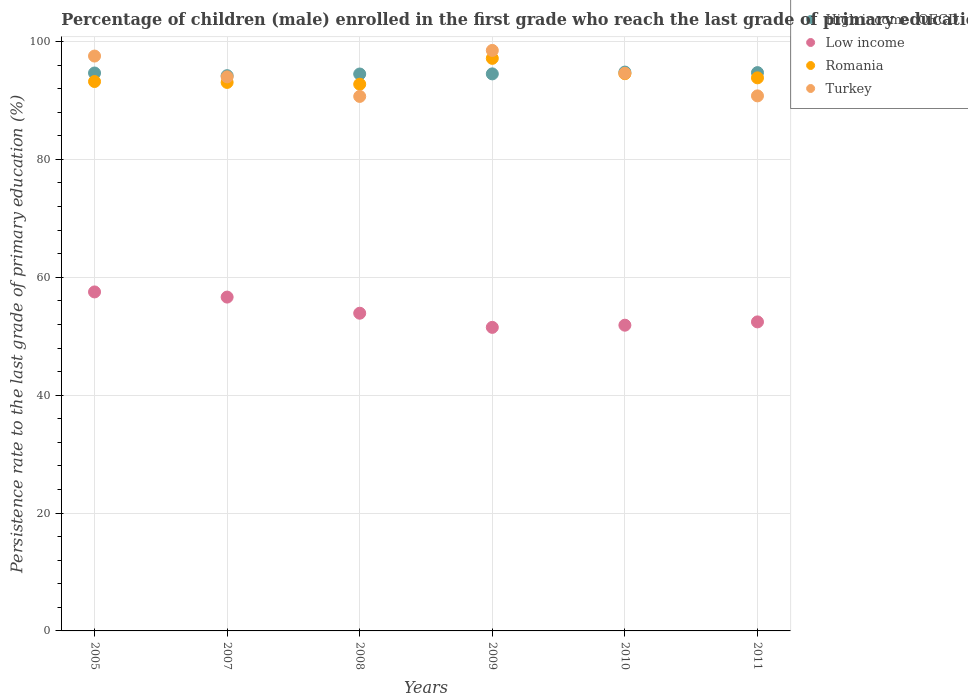Is the number of dotlines equal to the number of legend labels?
Your answer should be compact. Yes. What is the persistence rate of children in High income: OECD in 2010?
Your response must be concise. 94.81. Across all years, what is the maximum persistence rate of children in Romania?
Offer a very short reply. 97.14. Across all years, what is the minimum persistence rate of children in Romania?
Offer a terse response. 92.75. What is the total persistence rate of children in High income: OECD in the graph?
Keep it short and to the point. 567.39. What is the difference between the persistence rate of children in Turkey in 2009 and that in 2010?
Give a very brief answer. 3.88. What is the difference between the persistence rate of children in Low income in 2005 and the persistence rate of children in Romania in 2009?
Give a very brief answer. -39.63. What is the average persistence rate of children in Romania per year?
Offer a very short reply. 94.09. In the year 2011, what is the difference between the persistence rate of children in Low income and persistence rate of children in High income: OECD?
Your answer should be very brief. -42.29. What is the ratio of the persistence rate of children in Turkey in 2008 to that in 2010?
Offer a very short reply. 0.96. Is the persistence rate of children in High income: OECD in 2009 less than that in 2010?
Offer a terse response. Yes. Is the difference between the persistence rate of children in Low income in 2008 and 2010 greater than the difference between the persistence rate of children in High income: OECD in 2008 and 2010?
Offer a terse response. Yes. What is the difference between the highest and the second highest persistence rate of children in High income: OECD?
Provide a succinct answer. 0.09. What is the difference between the highest and the lowest persistence rate of children in High income: OECD?
Keep it short and to the point. 0.61. Is the sum of the persistence rate of children in Low income in 2005 and 2011 greater than the maximum persistence rate of children in Turkey across all years?
Give a very brief answer. Yes. Is it the case that in every year, the sum of the persistence rate of children in Turkey and persistence rate of children in Low income  is greater than the sum of persistence rate of children in Romania and persistence rate of children in High income: OECD?
Your answer should be very brief. No. Does the persistence rate of children in High income: OECD monotonically increase over the years?
Give a very brief answer. No. Is the persistence rate of children in Romania strictly less than the persistence rate of children in High income: OECD over the years?
Offer a terse response. No. How many dotlines are there?
Offer a very short reply. 4. How many years are there in the graph?
Your answer should be compact. 6. Are the values on the major ticks of Y-axis written in scientific E-notation?
Your answer should be compact. No. Does the graph contain any zero values?
Keep it short and to the point. No. Does the graph contain grids?
Offer a very short reply. Yes. What is the title of the graph?
Offer a terse response. Percentage of children (male) enrolled in the first grade who reach the last grade of primary education. What is the label or title of the X-axis?
Your response must be concise. Years. What is the label or title of the Y-axis?
Keep it short and to the point. Persistence rate to the last grade of primary education (%). What is the Persistence rate to the last grade of primary education (%) of High income: OECD in 2005?
Offer a very short reply. 94.66. What is the Persistence rate to the last grade of primary education (%) in Low income in 2005?
Provide a succinct answer. 57.51. What is the Persistence rate to the last grade of primary education (%) in Romania in 2005?
Offer a terse response. 93.21. What is the Persistence rate to the last grade of primary education (%) of Turkey in 2005?
Your answer should be compact. 97.53. What is the Persistence rate to the last grade of primary education (%) of High income: OECD in 2007?
Provide a short and direct response. 94.2. What is the Persistence rate to the last grade of primary education (%) in Low income in 2007?
Provide a succinct answer. 56.64. What is the Persistence rate to the last grade of primary education (%) of Romania in 2007?
Provide a short and direct response. 93.06. What is the Persistence rate to the last grade of primary education (%) of Turkey in 2007?
Offer a terse response. 94. What is the Persistence rate to the last grade of primary education (%) in High income: OECD in 2008?
Keep it short and to the point. 94.49. What is the Persistence rate to the last grade of primary education (%) in Low income in 2008?
Your answer should be very brief. 53.9. What is the Persistence rate to the last grade of primary education (%) of Romania in 2008?
Ensure brevity in your answer.  92.75. What is the Persistence rate to the last grade of primary education (%) of Turkey in 2008?
Provide a short and direct response. 90.68. What is the Persistence rate to the last grade of primary education (%) in High income: OECD in 2009?
Offer a terse response. 94.51. What is the Persistence rate to the last grade of primary education (%) in Low income in 2009?
Your answer should be very brief. 51.5. What is the Persistence rate to the last grade of primary education (%) of Romania in 2009?
Offer a terse response. 97.14. What is the Persistence rate to the last grade of primary education (%) of Turkey in 2009?
Offer a terse response. 98.49. What is the Persistence rate to the last grade of primary education (%) in High income: OECD in 2010?
Your response must be concise. 94.81. What is the Persistence rate to the last grade of primary education (%) in Low income in 2010?
Provide a succinct answer. 51.87. What is the Persistence rate to the last grade of primary education (%) in Romania in 2010?
Your response must be concise. 94.54. What is the Persistence rate to the last grade of primary education (%) of Turkey in 2010?
Provide a succinct answer. 94.61. What is the Persistence rate to the last grade of primary education (%) in High income: OECD in 2011?
Give a very brief answer. 94.72. What is the Persistence rate to the last grade of primary education (%) in Low income in 2011?
Your answer should be very brief. 52.43. What is the Persistence rate to the last grade of primary education (%) of Romania in 2011?
Give a very brief answer. 93.84. What is the Persistence rate to the last grade of primary education (%) of Turkey in 2011?
Offer a very short reply. 90.78. Across all years, what is the maximum Persistence rate to the last grade of primary education (%) of High income: OECD?
Provide a succinct answer. 94.81. Across all years, what is the maximum Persistence rate to the last grade of primary education (%) in Low income?
Offer a very short reply. 57.51. Across all years, what is the maximum Persistence rate to the last grade of primary education (%) in Romania?
Your answer should be very brief. 97.14. Across all years, what is the maximum Persistence rate to the last grade of primary education (%) of Turkey?
Your answer should be compact. 98.49. Across all years, what is the minimum Persistence rate to the last grade of primary education (%) in High income: OECD?
Give a very brief answer. 94.2. Across all years, what is the minimum Persistence rate to the last grade of primary education (%) in Low income?
Provide a succinct answer. 51.5. Across all years, what is the minimum Persistence rate to the last grade of primary education (%) of Romania?
Keep it short and to the point. 92.75. Across all years, what is the minimum Persistence rate to the last grade of primary education (%) of Turkey?
Your answer should be very brief. 90.68. What is the total Persistence rate to the last grade of primary education (%) in High income: OECD in the graph?
Provide a short and direct response. 567.39. What is the total Persistence rate to the last grade of primary education (%) in Low income in the graph?
Offer a very short reply. 323.85. What is the total Persistence rate to the last grade of primary education (%) of Romania in the graph?
Offer a terse response. 564.54. What is the total Persistence rate to the last grade of primary education (%) of Turkey in the graph?
Your answer should be compact. 566.09. What is the difference between the Persistence rate to the last grade of primary education (%) of High income: OECD in 2005 and that in 2007?
Provide a short and direct response. 0.45. What is the difference between the Persistence rate to the last grade of primary education (%) in Low income in 2005 and that in 2007?
Your answer should be very brief. 0.87. What is the difference between the Persistence rate to the last grade of primary education (%) in Romania in 2005 and that in 2007?
Provide a succinct answer. 0.15. What is the difference between the Persistence rate to the last grade of primary education (%) of Turkey in 2005 and that in 2007?
Your answer should be very brief. 3.53. What is the difference between the Persistence rate to the last grade of primary education (%) in High income: OECD in 2005 and that in 2008?
Your response must be concise. 0.17. What is the difference between the Persistence rate to the last grade of primary education (%) of Low income in 2005 and that in 2008?
Offer a very short reply. 3.61. What is the difference between the Persistence rate to the last grade of primary education (%) in Romania in 2005 and that in 2008?
Provide a short and direct response. 0.46. What is the difference between the Persistence rate to the last grade of primary education (%) of Turkey in 2005 and that in 2008?
Make the answer very short. 6.85. What is the difference between the Persistence rate to the last grade of primary education (%) in High income: OECD in 2005 and that in 2009?
Your response must be concise. 0.15. What is the difference between the Persistence rate to the last grade of primary education (%) of Low income in 2005 and that in 2009?
Your answer should be very brief. 6.01. What is the difference between the Persistence rate to the last grade of primary education (%) of Romania in 2005 and that in 2009?
Give a very brief answer. -3.93. What is the difference between the Persistence rate to the last grade of primary education (%) of Turkey in 2005 and that in 2009?
Keep it short and to the point. -0.95. What is the difference between the Persistence rate to the last grade of primary education (%) of High income: OECD in 2005 and that in 2010?
Keep it short and to the point. -0.16. What is the difference between the Persistence rate to the last grade of primary education (%) of Low income in 2005 and that in 2010?
Provide a short and direct response. 5.64. What is the difference between the Persistence rate to the last grade of primary education (%) in Romania in 2005 and that in 2010?
Offer a terse response. -1.33. What is the difference between the Persistence rate to the last grade of primary education (%) of Turkey in 2005 and that in 2010?
Provide a succinct answer. 2.92. What is the difference between the Persistence rate to the last grade of primary education (%) in High income: OECD in 2005 and that in 2011?
Offer a terse response. -0.07. What is the difference between the Persistence rate to the last grade of primary education (%) in Low income in 2005 and that in 2011?
Offer a very short reply. 5.08. What is the difference between the Persistence rate to the last grade of primary education (%) in Romania in 2005 and that in 2011?
Offer a very short reply. -0.62. What is the difference between the Persistence rate to the last grade of primary education (%) in Turkey in 2005 and that in 2011?
Make the answer very short. 6.76. What is the difference between the Persistence rate to the last grade of primary education (%) in High income: OECD in 2007 and that in 2008?
Make the answer very short. -0.28. What is the difference between the Persistence rate to the last grade of primary education (%) in Low income in 2007 and that in 2008?
Keep it short and to the point. 2.74. What is the difference between the Persistence rate to the last grade of primary education (%) in Romania in 2007 and that in 2008?
Provide a short and direct response. 0.3. What is the difference between the Persistence rate to the last grade of primary education (%) in Turkey in 2007 and that in 2008?
Give a very brief answer. 3.32. What is the difference between the Persistence rate to the last grade of primary education (%) in High income: OECD in 2007 and that in 2009?
Offer a terse response. -0.31. What is the difference between the Persistence rate to the last grade of primary education (%) of Low income in 2007 and that in 2009?
Ensure brevity in your answer.  5.14. What is the difference between the Persistence rate to the last grade of primary education (%) of Romania in 2007 and that in 2009?
Offer a terse response. -4.08. What is the difference between the Persistence rate to the last grade of primary education (%) in Turkey in 2007 and that in 2009?
Offer a very short reply. -4.49. What is the difference between the Persistence rate to the last grade of primary education (%) in High income: OECD in 2007 and that in 2010?
Give a very brief answer. -0.61. What is the difference between the Persistence rate to the last grade of primary education (%) in Low income in 2007 and that in 2010?
Give a very brief answer. 4.77. What is the difference between the Persistence rate to the last grade of primary education (%) of Romania in 2007 and that in 2010?
Your response must be concise. -1.48. What is the difference between the Persistence rate to the last grade of primary education (%) in Turkey in 2007 and that in 2010?
Provide a succinct answer. -0.61. What is the difference between the Persistence rate to the last grade of primary education (%) of High income: OECD in 2007 and that in 2011?
Give a very brief answer. -0.52. What is the difference between the Persistence rate to the last grade of primary education (%) of Low income in 2007 and that in 2011?
Provide a succinct answer. 4.21. What is the difference between the Persistence rate to the last grade of primary education (%) in Romania in 2007 and that in 2011?
Give a very brief answer. -0.78. What is the difference between the Persistence rate to the last grade of primary education (%) in Turkey in 2007 and that in 2011?
Make the answer very short. 3.23. What is the difference between the Persistence rate to the last grade of primary education (%) in High income: OECD in 2008 and that in 2009?
Keep it short and to the point. -0.02. What is the difference between the Persistence rate to the last grade of primary education (%) of Romania in 2008 and that in 2009?
Ensure brevity in your answer.  -4.39. What is the difference between the Persistence rate to the last grade of primary education (%) of Turkey in 2008 and that in 2009?
Your response must be concise. -7.8. What is the difference between the Persistence rate to the last grade of primary education (%) of High income: OECD in 2008 and that in 2010?
Provide a succinct answer. -0.33. What is the difference between the Persistence rate to the last grade of primary education (%) of Low income in 2008 and that in 2010?
Offer a terse response. 2.03. What is the difference between the Persistence rate to the last grade of primary education (%) in Romania in 2008 and that in 2010?
Offer a very short reply. -1.79. What is the difference between the Persistence rate to the last grade of primary education (%) in Turkey in 2008 and that in 2010?
Offer a terse response. -3.92. What is the difference between the Persistence rate to the last grade of primary education (%) of High income: OECD in 2008 and that in 2011?
Provide a short and direct response. -0.24. What is the difference between the Persistence rate to the last grade of primary education (%) of Low income in 2008 and that in 2011?
Keep it short and to the point. 1.47. What is the difference between the Persistence rate to the last grade of primary education (%) of Romania in 2008 and that in 2011?
Your response must be concise. -1.08. What is the difference between the Persistence rate to the last grade of primary education (%) in Turkey in 2008 and that in 2011?
Offer a very short reply. -0.09. What is the difference between the Persistence rate to the last grade of primary education (%) of High income: OECD in 2009 and that in 2010?
Make the answer very short. -0.31. What is the difference between the Persistence rate to the last grade of primary education (%) of Low income in 2009 and that in 2010?
Make the answer very short. -0.37. What is the difference between the Persistence rate to the last grade of primary education (%) in Romania in 2009 and that in 2010?
Make the answer very short. 2.6. What is the difference between the Persistence rate to the last grade of primary education (%) in Turkey in 2009 and that in 2010?
Provide a succinct answer. 3.88. What is the difference between the Persistence rate to the last grade of primary education (%) of High income: OECD in 2009 and that in 2011?
Your response must be concise. -0.22. What is the difference between the Persistence rate to the last grade of primary education (%) of Low income in 2009 and that in 2011?
Offer a very short reply. -0.93. What is the difference between the Persistence rate to the last grade of primary education (%) in Romania in 2009 and that in 2011?
Keep it short and to the point. 3.31. What is the difference between the Persistence rate to the last grade of primary education (%) of Turkey in 2009 and that in 2011?
Your answer should be compact. 7.71. What is the difference between the Persistence rate to the last grade of primary education (%) of High income: OECD in 2010 and that in 2011?
Your answer should be very brief. 0.09. What is the difference between the Persistence rate to the last grade of primary education (%) in Low income in 2010 and that in 2011?
Offer a terse response. -0.56. What is the difference between the Persistence rate to the last grade of primary education (%) in Romania in 2010 and that in 2011?
Keep it short and to the point. 0.71. What is the difference between the Persistence rate to the last grade of primary education (%) of Turkey in 2010 and that in 2011?
Your response must be concise. 3.83. What is the difference between the Persistence rate to the last grade of primary education (%) of High income: OECD in 2005 and the Persistence rate to the last grade of primary education (%) of Low income in 2007?
Provide a short and direct response. 38.02. What is the difference between the Persistence rate to the last grade of primary education (%) in High income: OECD in 2005 and the Persistence rate to the last grade of primary education (%) in Romania in 2007?
Ensure brevity in your answer.  1.6. What is the difference between the Persistence rate to the last grade of primary education (%) of High income: OECD in 2005 and the Persistence rate to the last grade of primary education (%) of Turkey in 2007?
Ensure brevity in your answer.  0.65. What is the difference between the Persistence rate to the last grade of primary education (%) in Low income in 2005 and the Persistence rate to the last grade of primary education (%) in Romania in 2007?
Your response must be concise. -35.54. What is the difference between the Persistence rate to the last grade of primary education (%) of Low income in 2005 and the Persistence rate to the last grade of primary education (%) of Turkey in 2007?
Ensure brevity in your answer.  -36.49. What is the difference between the Persistence rate to the last grade of primary education (%) in Romania in 2005 and the Persistence rate to the last grade of primary education (%) in Turkey in 2007?
Provide a short and direct response. -0.79. What is the difference between the Persistence rate to the last grade of primary education (%) in High income: OECD in 2005 and the Persistence rate to the last grade of primary education (%) in Low income in 2008?
Ensure brevity in your answer.  40.75. What is the difference between the Persistence rate to the last grade of primary education (%) of High income: OECD in 2005 and the Persistence rate to the last grade of primary education (%) of Romania in 2008?
Offer a terse response. 1.9. What is the difference between the Persistence rate to the last grade of primary education (%) of High income: OECD in 2005 and the Persistence rate to the last grade of primary education (%) of Turkey in 2008?
Your response must be concise. 3.97. What is the difference between the Persistence rate to the last grade of primary education (%) of Low income in 2005 and the Persistence rate to the last grade of primary education (%) of Romania in 2008?
Your response must be concise. -35.24. What is the difference between the Persistence rate to the last grade of primary education (%) in Low income in 2005 and the Persistence rate to the last grade of primary education (%) in Turkey in 2008?
Ensure brevity in your answer.  -33.17. What is the difference between the Persistence rate to the last grade of primary education (%) of Romania in 2005 and the Persistence rate to the last grade of primary education (%) of Turkey in 2008?
Offer a terse response. 2.53. What is the difference between the Persistence rate to the last grade of primary education (%) in High income: OECD in 2005 and the Persistence rate to the last grade of primary education (%) in Low income in 2009?
Provide a succinct answer. 43.15. What is the difference between the Persistence rate to the last grade of primary education (%) in High income: OECD in 2005 and the Persistence rate to the last grade of primary education (%) in Romania in 2009?
Offer a terse response. -2.49. What is the difference between the Persistence rate to the last grade of primary education (%) in High income: OECD in 2005 and the Persistence rate to the last grade of primary education (%) in Turkey in 2009?
Your answer should be compact. -3.83. What is the difference between the Persistence rate to the last grade of primary education (%) of Low income in 2005 and the Persistence rate to the last grade of primary education (%) of Romania in 2009?
Ensure brevity in your answer.  -39.63. What is the difference between the Persistence rate to the last grade of primary education (%) in Low income in 2005 and the Persistence rate to the last grade of primary education (%) in Turkey in 2009?
Your answer should be very brief. -40.97. What is the difference between the Persistence rate to the last grade of primary education (%) of Romania in 2005 and the Persistence rate to the last grade of primary education (%) of Turkey in 2009?
Your answer should be very brief. -5.28. What is the difference between the Persistence rate to the last grade of primary education (%) in High income: OECD in 2005 and the Persistence rate to the last grade of primary education (%) in Low income in 2010?
Keep it short and to the point. 42.79. What is the difference between the Persistence rate to the last grade of primary education (%) of High income: OECD in 2005 and the Persistence rate to the last grade of primary education (%) of Romania in 2010?
Your answer should be very brief. 0.11. What is the difference between the Persistence rate to the last grade of primary education (%) in High income: OECD in 2005 and the Persistence rate to the last grade of primary education (%) in Turkey in 2010?
Your answer should be compact. 0.05. What is the difference between the Persistence rate to the last grade of primary education (%) of Low income in 2005 and the Persistence rate to the last grade of primary education (%) of Romania in 2010?
Give a very brief answer. -37.03. What is the difference between the Persistence rate to the last grade of primary education (%) in Low income in 2005 and the Persistence rate to the last grade of primary education (%) in Turkey in 2010?
Ensure brevity in your answer.  -37.1. What is the difference between the Persistence rate to the last grade of primary education (%) of Romania in 2005 and the Persistence rate to the last grade of primary education (%) of Turkey in 2010?
Your response must be concise. -1.4. What is the difference between the Persistence rate to the last grade of primary education (%) in High income: OECD in 2005 and the Persistence rate to the last grade of primary education (%) in Low income in 2011?
Ensure brevity in your answer.  42.23. What is the difference between the Persistence rate to the last grade of primary education (%) of High income: OECD in 2005 and the Persistence rate to the last grade of primary education (%) of Romania in 2011?
Your response must be concise. 0.82. What is the difference between the Persistence rate to the last grade of primary education (%) of High income: OECD in 2005 and the Persistence rate to the last grade of primary education (%) of Turkey in 2011?
Your answer should be compact. 3.88. What is the difference between the Persistence rate to the last grade of primary education (%) of Low income in 2005 and the Persistence rate to the last grade of primary education (%) of Romania in 2011?
Your response must be concise. -36.32. What is the difference between the Persistence rate to the last grade of primary education (%) of Low income in 2005 and the Persistence rate to the last grade of primary education (%) of Turkey in 2011?
Provide a short and direct response. -33.26. What is the difference between the Persistence rate to the last grade of primary education (%) in Romania in 2005 and the Persistence rate to the last grade of primary education (%) in Turkey in 2011?
Ensure brevity in your answer.  2.44. What is the difference between the Persistence rate to the last grade of primary education (%) in High income: OECD in 2007 and the Persistence rate to the last grade of primary education (%) in Low income in 2008?
Your answer should be compact. 40.3. What is the difference between the Persistence rate to the last grade of primary education (%) in High income: OECD in 2007 and the Persistence rate to the last grade of primary education (%) in Romania in 2008?
Ensure brevity in your answer.  1.45. What is the difference between the Persistence rate to the last grade of primary education (%) of High income: OECD in 2007 and the Persistence rate to the last grade of primary education (%) of Turkey in 2008?
Provide a short and direct response. 3.52. What is the difference between the Persistence rate to the last grade of primary education (%) in Low income in 2007 and the Persistence rate to the last grade of primary education (%) in Romania in 2008?
Provide a succinct answer. -36.11. What is the difference between the Persistence rate to the last grade of primary education (%) in Low income in 2007 and the Persistence rate to the last grade of primary education (%) in Turkey in 2008?
Provide a short and direct response. -34.05. What is the difference between the Persistence rate to the last grade of primary education (%) in Romania in 2007 and the Persistence rate to the last grade of primary education (%) in Turkey in 2008?
Make the answer very short. 2.37. What is the difference between the Persistence rate to the last grade of primary education (%) in High income: OECD in 2007 and the Persistence rate to the last grade of primary education (%) in Low income in 2009?
Make the answer very short. 42.7. What is the difference between the Persistence rate to the last grade of primary education (%) in High income: OECD in 2007 and the Persistence rate to the last grade of primary education (%) in Romania in 2009?
Provide a short and direct response. -2.94. What is the difference between the Persistence rate to the last grade of primary education (%) in High income: OECD in 2007 and the Persistence rate to the last grade of primary education (%) in Turkey in 2009?
Provide a short and direct response. -4.29. What is the difference between the Persistence rate to the last grade of primary education (%) of Low income in 2007 and the Persistence rate to the last grade of primary education (%) of Romania in 2009?
Ensure brevity in your answer.  -40.5. What is the difference between the Persistence rate to the last grade of primary education (%) in Low income in 2007 and the Persistence rate to the last grade of primary education (%) in Turkey in 2009?
Give a very brief answer. -41.85. What is the difference between the Persistence rate to the last grade of primary education (%) in Romania in 2007 and the Persistence rate to the last grade of primary education (%) in Turkey in 2009?
Offer a terse response. -5.43. What is the difference between the Persistence rate to the last grade of primary education (%) in High income: OECD in 2007 and the Persistence rate to the last grade of primary education (%) in Low income in 2010?
Ensure brevity in your answer.  42.33. What is the difference between the Persistence rate to the last grade of primary education (%) in High income: OECD in 2007 and the Persistence rate to the last grade of primary education (%) in Romania in 2010?
Your response must be concise. -0.34. What is the difference between the Persistence rate to the last grade of primary education (%) in High income: OECD in 2007 and the Persistence rate to the last grade of primary education (%) in Turkey in 2010?
Give a very brief answer. -0.41. What is the difference between the Persistence rate to the last grade of primary education (%) of Low income in 2007 and the Persistence rate to the last grade of primary education (%) of Romania in 2010?
Your response must be concise. -37.9. What is the difference between the Persistence rate to the last grade of primary education (%) in Low income in 2007 and the Persistence rate to the last grade of primary education (%) in Turkey in 2010?
Your answer should be compact. -37.97. What is the difference between the Persistence rate to the last grade of primary education (%) in Romania in 2007 and the Persistence rate to the last grade of primary education (%) in Turkey in 2010?
Your answer should be compact. -1.55. What is the difference between the Persistence rate to the last grade of primary education (%) of High income: OECD in 2007 and the Persistence rate to the last grade of primary education (%) of Low income in 2011?
Your answer should be compact. 41.77. What is the difference between the Persistence rate to the last grade of primary education (%) of High income: OECD in 2007 and the Persistence rate to the last grade of primary education (%) of Romania in 2011?
Make the answer very short. 0.37. What is the difference between the Persistence rate to the last grade of primary education (%) of High income: OECD in 2007 and the Persistence rate to the last grade of primary education (%) of Turkey in 2011?
Your response must be concise. 3.43. What is the difference between the Persistence rate to the last grade of primary education (%) in Low income in 2007 and the Persistence rate to the last grade of primary education (%) in Romania in 2011?
Provide a short and direct response. -37.2. What is the difference between the Persistence rate to the last grade of primary education (%) of Low income in 2007 and the Persistence rate to the last grade of primary education (%) of Turkey in 2011?
Provide a succinct answer. -34.14. What is the difference between the Persistence rate to the last grade of primary education (%) in Romania in 2007 and the Persistence rate to the last grade of primary education (%) in Turkey in 2011?
Offer a very short reply. 2.28. What is the difference between the Persistence rate to the last grade of primary education (%) in High income: OECD in 2008 and the Persistence rate to the last grade of primary education (%) in Low income in 2009?
Ensure brevity in your answer.  42.99. What is the difference between the Persistence rate to the last grade of primary education (%) in High income: OECD in 2008 and the Persistence rate to the last grade of primary education (%) in Romania in 2009?
Make the answer very short. -2.65. What is the difference between the Persistence rate to the last grade of primary education (%) of High income: OECD in 2008 and the Persistence rate to the last grade of primary education (%) of Turkey in 2009?
Make the answer very short. -4. What is the difference between the Persistence rate to the last grade of primary education (%) in Low income in 2008 and the Persistence rate to the last grade of primary education (%) in Romania in 2009?
Your answer should be compact. -43.24. What is the difference between the Persistence rate to the last grade of primary education (%) of Low income in 2008 and the Persistence rate to the last grade of primary education (%) of Turkey in 2009?
Your answer should be compact. -44.59. What is the difference between the Persistence rate to the last grade of primary education (%) in Romania in 2008 and the Persistence rate to the last grade of primary education (%) in Turkey in 2009?
Keep it short and to the point. -5.73. What is the difference between the Persistence rate to the last grade of primary education (%) of High income: OECD in 2008 and the Persistence rate to the last grade of primary education (%) of Low income in 2010?
Your response must be concise. 42.62. What is the difference between the Persistence rate to the last grade of primary education (%) in High income: OECD in 2008 and the Persistence rate to the last grade of primary education (%) in Romania in 2010?
Provide a short and direct response. -0.05. What is the difference between the Persistence rate to the last grade of primary education (%) of High income: OECD in 2008 and the Persistence rate to the last grade of primary education (%) of Turkey in 2010?
Offer a very short reply. -0.12. What is the difference between the Persistence rate to the last grade of primary education (%) of Low income in 2008 and the Persistence rate to the last grade of primary education (%) of Romania in 2010?
Your response must be concise. -40.64. What is the difference between the Persistence rate to the last grade of primary education (%) in Low income in 2008 and the Persistence rate to the last grade of primary education (%) in Turkey in 2010?
Make the answer very short. -40.71. What is the difference between the Persistence rate to the last grade of primary education (%) of Romania in 2008 and the Persistence rate to the last grade of primary education (%) of Turkey in 2010?
Ensure brevity in your answer.  -1.85. What is the difference between the Persistence rate to the last grade of primary education (%) in High income: OECD in 2008 and the Persistence rate to the last grade of primary education (%) in Low income in 2011?
Provide a succinct answer. 42.06. What is the difference between the Persistence rate to the last grade of primary education (%) in High income: OECD in 2008 and the Persistence rate to the last grade of primary education (%) in Romania in 2011?
Your response must be concise. 0.65. What is the difference between the Persistence rate to the last grade of primary education (%) of High income: OECD in 2008 and the Persistence rate to the last grade of primary education (%) of Turkey in 2011?
Provide a short and direct response. 3.71. What is the difference between the Persistence rate to the last grade of primary education (%) of Low income in 2008 and the Persistence rate to the last grade of primary education (%) of Romania in 2011?
Provide a succinct answer. -39.93. What is the difference between the Persistence rate to the last grade of primary education (%) of Low income in 2008 and the Persistence rate to the last grade of primary education (%) of Turkey in 2011?
Offer a very short reply. -36.87. What is the difference between the Persistence rate to the last grade of primary education (%) of Romania in 2008 and the Persistence rate to the last grade of primary education (%) of Turkey in 2011?
Your response must be concise. 1.98. What is the difference between the Persistence rate to the last grade of primary education (%) of High income: OECD in 2009 and the Persistence rate to the last grade of primary education (%) of Low income in 2010?
Provide a succinct answer. 42.64. What is the difference between the Persistence rate to the last grade of primary education (%) of High income: OECD in 2009 and the Persistence rate to the last grade of primary education (%) of Romania in 2010?
Your response must be concise. -0.03. What is the difference between the Persistence rate to the last grade of primary education (%) of High income: OECD in 2009 and the Persistence rate to the last grade of primary education (%) of Turkey in 2010?
Make the answer very short. -0.1. What is the difference between the Persistence rate to the last grade of primary education (%) of Low income in 2009 and the Persistence rate to the last grade of primary education (%) of Romania in 2010?
Keep it short and to the point. -43.04. What is the difference between the Persistence rate to the last grade of primary education (%) of Low income in 2009 and the Persistence rate to the last grade of primary education (%) of Turkey in 2010?
Provide a short and direct response. -43.11. What is the difference between the Persistence rate to the last grade of primary education (%) of Romania in 2009 and the Persistence rate to the last grade of primary education (%) of Turkey in 2010?
Your answer should be very brief. 2.53. What is the difference between the Persistence rate to the last grade of primary education (%) in High income: OECD in 2009 and the Persistence rate to the last grade of primary education (%) in Low income in 2011?
Your answer should be compact. 42.08. What is the difference between the Persistence rate to the last grade of primary education (%) of High income: OECD in 2009 and the Persistence rate to the last grade of primary education (%) of Romania in 2011?
Ensure brevity in your answer.  0.67. What is the difference between the Persistence rate to the last grade of primary education (%) in High income: OECD in 2009 and the Persistence rate to the last grade of primary education (%) in Turkey in 2011?
Your response must be concise. 3.73. What is the difference between the Persistence rate to the last grade of primary education (%) in Low income in 2009 and the Persistence rate to the last grade of primary education (%) in Romania in 2011?
Provide a succinct answer. -42.33. What is the difference between the Persistence rate to the last grade of primary education (%) of Low income in 2009 and the Persistence rate to the last grade of primary education (%) of Turkey in 2011?
Provide a short and direct response. -39.27. What is the difference between the Persistence rate to the last grade of primary education (%) of Romania in 2009 and the Persistence rate to the last grade of primary education (%) of Turkey in 2011?
Provide a succinct answer. 6.37. What is the difference between the Persistence rate to the last grade of primary education (%) in High income: OECD in 2010 and the Persistence rate to the last grade of primary education (%) in Low income in 2011?
Your answer should be very brief. 42.38. What is the difference between the Persistence rate to the last grade of primary education (%) of High income: OECD in 2010 and the Persistence rate to the last grade of primary education (%) of Romania in 2011?
Offer a terse response. 0.98. What is the difference between the Persistence rate to the last grade of primary education (%) in High income: OECD in 2010 and the Persistence rate to the last grade of primary education (%) in Turkey in 2011?
Offer a very short reply. 4.04. What is the difference between the Persistence rate to the last grade of primary education (%) of Low income in 2010 and the Persistence rate to the last grade of primary education (%) of Romania in 2011?
Your answer should be compact. -41.97. What is the difference between the Persistence rate to the last grade of primary education (%) of Low income in 2010 and the Persistence rate to the last grade of primary education (%) of Turkey in 2011?
Ensure brevity in your answer.  -38.91. What is the difference between the Persistence rate to the last grade of primary education (%) of Romania in 2010 and the Persistence rate to the last grade of primary education (%) of Turkey in 2011?
Offer a terse response. 3.77. What is the average Persistence rate to the last grade of primary education (%) of High income: OECD per year?
Make the answer very short. 94.56. What is the average Persistence rate to the last grade of primary education (%) in Low income per year?
Ensure brevity in your answer.  53.98. What is the average Persistence rate to the last grade of primary education (%) in Romania per year?
Your answer should be very brief. 94.09. What is the average Persistence rate to the last grade of primary education (%) in Turkey per year?
Make the answer very short. 94.35. In the year 2005, what is the difference between the Persistence rate to the last grade of primary education (%) of High income: OECD and Persistence rate to the last grade of primary education (%) of Low income?
Your answer should be very brief. 37.14. In the year 2005, what is the difference between the Persistence rate to the last grade of primary education (%) of High income: OECD and Persistence rate to the last grade of primary education (%) of Romania?
Provide a short and direct response. 1.44. In the year 2005, what is the difference between the Persistence rate to the last grade of primary education (%) of High income: OECD and Persistence rate to the last grade of primary education (%) of Turkey?
Give a very brief answer. -2.88. In the year 2005, what is the difference between the Persistence rate to the last grade of primary education (%) in Low income and Persistence rate to the last grade of primary education (%) in Romania?
Your answer should be very brief. -35.7. In the year 2005, what is the difference between the Persistence rate to the last grade of primary education (%) of Low income and Persistence rate to the last grade of primary education (%) of Turkey?
Your answer should be very brief. -40.02. In the year 2005, what is the difference between the Persistence rate to the last grade of primary education (%) in Romania and Persistence rate to the last grade of primary education (%) in Turkey?
Ensure brevity in your answer.  -4.32. In the year 2007, what is the difference between the Persistence rate to the last grade of primary education (%) of High income: OECD and Persistence rate to the last grade of primary education (%) of Low income?
Provide a short and direct response. 37.56. In the year 2007, what is the difference between the Persistence rate to the last grade of primary education (%) in High income: OECD and Persistence rate to the last grade of primary education (%) in Romania?
Keep it short and to the point. 1.14. In the year 2007, what is the difference between the Persistence rate to the last grade of primary education (%) of High income: OECD and Persistence rate to the last grade of primary education (%) of Turkey?
Make the answer very short. 0.2. In the year 2007, what is the difference between the Persistence rate to the last grade of primary education (%) in Low income and Persistence rate to the last grade of primary education (%) in Romania?
Give a very brief answer. -36.42. In the year 2007, what is the difference between the Persistence rate to the last grade of primary education (%) of Low income and Persistence rate to the last grade of primary education (%) of Turkey?
Your answer should be compact. -37.36. In the year 2007, what is the difference between the Persistence rate to the last grade of primary education (%) of Romania and Persistence rate to the last grade of primary education (%) of Turkey?
Make the answer very short. -0.94. In the year 2008, what is the difference between the Persistence rate to the last grade of primary education (%) in High income: OECD and Persistence rate to the last grade of primary education (%) in Low income?
Ensure brevity in your answer.  40.59. In the year 2008, what is the difference between the Persistence rate to the last grade of primary education (%) in High income: OECD and Persistence rate to the last grade of primary education (%) in Romania?
Provide a short and direct response. 1.73. In the year 2008, what is the difference between the Persistence rate to the last grade of primary education (%) in High income: OECD and Persistence rate to the last grade of primary education (%) in Turkey?
Give a very brief answer. 3.8. In the year 2008, what is the difference between the Persistence rate to the last grade of primary education (%) of Low income and Persistence rate to the last grade of primary education (%) of Romania?
Your response must be concise. -38.85. In the year 2008, what is the difference between the Persistence rate to the last grade of primary education (%) of Low income and Persistence rate to the last grade of primary education (%) of Turkey?
Keep it short and to the point. -36.78. In the year 2008, what is the difference between the Persistence rate to the last grade of primary education (%) of Romania and Persistence rate to the last grade of primary education (%) of Turkey?
Ensure brevity in your answer.  2.07. In the year 2009, what is the difference between the Persistence rate to the last grade of primary education (%) in High income: OECD and Persistence rate to the last grade of primary education (%) in Low income?
Ensure brevity in your answer.  43.01. In the year 2009, what is the difference between the Persistence rate to the last grade of primary education (%) in High income: OECD and Persistence rate to the last grade of primary education (%) in Romania?
Keep it short and to the point. -2.63. In the year 2009, what is the difference between the Persistence rate to the last grade of primary education (%) of High income: OECD and Persistence rate to the last grade of primary education (%) of Turkey?
Your answer should be very brief. -3.98. In the year 2009, what is the difference between the Persistence rate to the last grade of primary education (%) of Low income and Persistence rate to the last grade of primary education (%) of Romania?
Offer a very short reply. -45.64. In the year 2009, what is the difference between the Persistence rate to the last grade of primary education (%) in Low income and Persistence rate to the last grade of primary education (%) in Turkey?
Offer a terse response. -46.99. In the year 2009, what is the difference between the Persistence rate to the last grade of primary education (%) of Romania and Persistence rate to the last grade of primary education (%) of Turkey?
Keep it short and to the point. -1.35. In the year 2010, what is the difference between the Persistence rate to the last grade of primary education (%) of High income: OECD and Persistence rate to the last grade of primary education (%) of Low income?
Offer a very short reply. 42.94. In the year 2010, what is the difference between the Persistence rate to the last grade of primary education (%) of High income: OECD and Persistence rate to the last grade of primary education (%) of Romania?
Offer a very short reply. 0.27. In the year 2010, what is the difference between the Persistence rate to the last grade of primary education (%) in High income: OECD and Persistence rate to the last grade of primary education (%) in Turkey?
Ensure brevity in your answer.  0.2. In the year 2010, what is the difference between the Persistence rate to the last grade of primary education (%) of Low income and Persistence rate to the last grade of primary education (%) of Romania?
Your response must be concise. -42.67. In the year 2010, what is the difference between the Persistence rate to the last grade of primary education (%) of Low income and Persistence rate to the last grade of primary education (%) of Turkey?
Give a very brief answer. -42.74. In the year 2010, what is the difference between the Persistence rate to the last grade of primary education (%) in Romania and Persistence rate to the last grade of primary education (%) in Turkey?
Keep it short and to the point. -0.07. In the year 2011, what is the difference between the Persistence rate to the last grade of primary education (%) in High income: OECD and Persistence rate to the last grade of primary education (%) in Low income?
Ensure brevity in your answer.  42.29. In the year 2011, what is the difference between the Persistence rate to the last grade of primary education (%) of High income: OECD and Persistence rate to the last grade of primary education (%) of Romania?
Provide a succinct answer. 0.89. In the year 2011, what is the difference between the Persistence rate to the last grade of primary education (%) in High income: OECD and Persistence rate to the last grade of primary education (%) in Turkey?
Provide a succinct answer. 3.95. In the year 2011, what is the difference between the Persistence rate to the last grade of primary education (%) in Low income and Persistence rate to the last grade of primary education (%) in Romania?
Provide a succinct answer. -41.41. In the year 2011, what is the difference between the Persistence rate to the last grade of primary education (%) in Low income and Persistence rate to the last grade of primary education (%) in Turkey?
Keep it short and to the point. -38.34. In the year 2011, what is the difference between the Persistence rate to the last grade of primary education (%) in Romania and Persistence rate to the last grade of primary education (%) in Turkey?
Ensure brevity in your answer.  3.06. What is the ratio of the Persistence rate to the last grade of primary education (%) of Low income in 2005 to that in 2007?
Offer a very short reply. 1.02. What is the ratio of the Persistence rate to the last grade of primary education (%) of Romania in 2005 to that in 2007?
Your answer should be compact. 1. What is the ratio of the Persistence rate to the last grade of primary education (%) of Turkey in 2005 to that in 2007?
Provide a succinct answer. 1.04. What is the ratio of the Persistence rate to the last grade of primary education (%) of High income: OECD in 2005 to that in 2008?
Make the answer very short. 1. What is the ratio of the Persistence rate to the last grade of primary education (%) of Low income in 2005 to that in 2008?
Your response must be concise. 1.07. What is the ratio of the Persistence rate to the last grade of primary education (%) of Turkey in 2005 to that in 2008?
Offer a very short reply. 1.08. What is the ratio of the Persistence rate to the last grade of primary education (%) in High income: OECD in 2005 to that in 2009?
Offer a terse response. 1. What is the ratio of the Persistence rate to the last grade of primary education (%) of Low income in 2005 to that in 2009?
Offer a very short reply. 1.12. What is the ratio of the Persistence rate to the last grade of primary education (%) of Romania in 2005 to that in 2009?
Give a very brief answer. 0.96. What is the ratio of the Persistence rate to the last grade of primary education (%) of Turkey in 2005 to that in 2009?
Offer a very short reply. 0.99. What is the ratio of the Persistence rate to the last grade of primary education (%) in Low income in 2005 to that in 2010?
Ensure brevity in your answer.  1.11. What is the ratio of the Persistence rate to the last grade of primary education (%) in Romania in 2005 to that in 2010?
Offer a very short reply. 0.99. What is the ratio of the Persistence rate to the last grade of primary education (%) in Turkey in 2005 to that in 2010?
Give a very brief answer. 1.03. What is the ratio of the Persistence rate to the last grade of primary education (%) in Low income in 2005 to that in 2011?
Offer a terse response. 1.1. What is the ratio of the Persistence rate to the last grade of primary education (%) of Romania in 2005 to that in 2011?
Offer a terse response. 0.99. What is the ratio of the Persistence rate to the last grade of primary education (%) of Turkey in 2005 to that in 2011?
Ensure brevity in your answer.  1.07. What is the ratio of the Persistence rate to the last grade of primary education (%) in Low income in 2007 to that in 2008?
Offer a terse response. 1.05. What is the ratio of the Persistence rate to the last grade of primary education (%) of Romania in 2007 to that in 2008?
Provide a short and direct response. 1. What is the ratio of the Persistence rate to the last grade of primary education (%) in Turkey in 2007 to that in 2008?
Your answer should be compact. 1.04. What is the ratio of the Persistence rate to the last grade of primary education (%) of Low income in 2007 to that in 2009?
Give a very brief answer. 1.1. What is the ratio of the Persistence rate to the last grade of primary education (%) in Romania in 2007 to that in 2009?
Offer a very short reply. 0.96. What is the ratio of the Persistence rate to the last grade of primary education (%) of Turkey in 2007 to that in 2009?
Offer a terse response. 0.95. What is the ratio of the Persistence rate to the last grade of primary education (%) of Low income in 2007 to that in 2010?
Give a very brief answer. 1.09. What is the ratio of the Persistence rate to the last grade of primary education (%) of Romania in 2007 to that in 2010?
Provide a short and direct response. 0.98. What is the ratio of the Persistence rate to the last grade of primary education (%) of High income: OECD in 2007 to that in 2011?
Provide a succinct answer. 0.99. What is the ratio of the Persistence rate to the last grade of primary education (%) of Low income in 2007 to that in 2011?
Keep it short and to the point. 1.08. What is the ratio of the Persistence rate to the last grade of primary education (%) of Turkey in 2007 to that in 2011?
Offer a very short reply. 1.04. What is the ratio of the Persistence rate to the last grade of primary education (%) of Low income in 2008 to that in 2009?
Keep it short and to the point. 1.05. What is the ratio of the Persistence rate to the last grade of primary education (%) of Romania in 2008 to that in 2009?
Your response must be concise. 0.95. What is the ratio of the Persistence rate to the last grade of primary education (%) in Turkey in 2008 to that in 2009?
Make the answer very short. 0.92. What is the ratio of the Persistence rate to the last grade of primary education (%) in Low income in 2008 to that in 2010?
Ensure brevity in your answer.  1.04. What is the ratio of the Persistence rate to the last grade of primary education (%) of Romania in 2008 to that in 2010?
Make the answer very short. 0.98. What is the ratio of the Persistence rate to the last grade of primary education (%) in Turkey in 2008 to that in 2010?
Offer a very short reply. 0.96. What is the ratio of the Persistence rate to the last grade of primary education (%) of High income: OECD in 2008 to that in 2011?
Keep it short and to the point. 1. What is the ratio of the Persistence rate to the last grade of primary education (%) of Low income in 2008 to that in 2011?
Offer a terse response. 1.03. What is the ratio of the Persistence rate to the last grade of primary education (%) in Romania in 2008 to that in 2011?
Give a very brief answer. 0.99. What is the ratio of the Persistence rate to the last grade of primary education (%) of Turkey in 2008 to that in 2011?
Provide a succinct answer. 1. What is the ratio of the Persistence rate to the last grade of primary education (%) of Romania in 2009 to that in 2010?
Keep it short and to the point. 1.03. What is the ratio of the Persistence rate to the last grade of primary education (%) in Turkey in 2009 to that in 2010?
Provide a short and direct response. 1.04. What is the ratio of the Persistence rate to the last grade of primary education (%) of Low income in 2009 to that in 2011?
Your answer should be very brief. 0.98. What is the ratio of the Persistence rate to the last grade of primary education (%) of Romania in 2009 to that in 2011?
Make the answer very short. 1.04. What is the ratio of the Persistence rate to the last grade of primary education (%) in Turkey in 2009 to that in 2011?
Offer a terse response. 1.08. What is the ratio of the Persistence rate to the last grade of primary education (%) in High income: OECD in 2010 to that in 2011?
Make the answer very short. 1. What is the ratio of the Persistence rate to the last grade of primary education (%) of Low income in 2010 to that in 2011?
Give a very brief answer. 0.99. What is the ratio of the Persistence rate to the last grade of primary education (%) in Romania in 2010 to that in 2011?
Offer a terse response. 1.01. What is the ratio of the Persistence rate to the last grade of primary education (%) of Turkey in 2010 to that in 2011?
Make the answer very short. 1.04. What is the difference between the highest and the second highest Persistence rate to the last grade of primary education (%) of High income: OECD?
Offer a very short reply. 0.09. What is the difference between the highest and the second highest Persistence rate to the last grade of primary education (%) in Low income?
Ensure brevity in your answer.  0.87. What is the difference between the highest and the second highest Persistence rate to the last grade of primary education (%) in Romania?
Keep it short and to the point. 2.6. What is the difference between the highest and the second highest Persistence rate to the last grade of primary education (%) in Turkey?
Give a very brief answer. 0.95. What is the difference between the highest and the lowest Persistence rate to the last grade of primary education (%) of High income: OECD?
Offer a terse response. 0.61. What is the difference between the highest and the lowest Persistence rate to the last grade of primary education (%) in Low income?
Keep it short and to the point. 6.01. What is the difference between the highest and the lowest Persistence rate to the last grade of primary education (%) of Romania?
Make the answer very short. 4.39. What is the difference between the highest and the lowest Persistence rate to the last grade of primary education (%) of Turkey?
Provide a succinct answer. 7.8. 